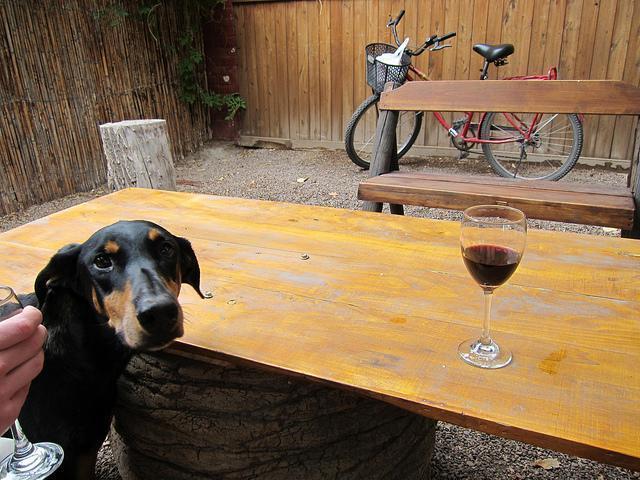Evaluate: Does the caption "The person is touching the dining table." match the image?
Answer yes or no. No. 